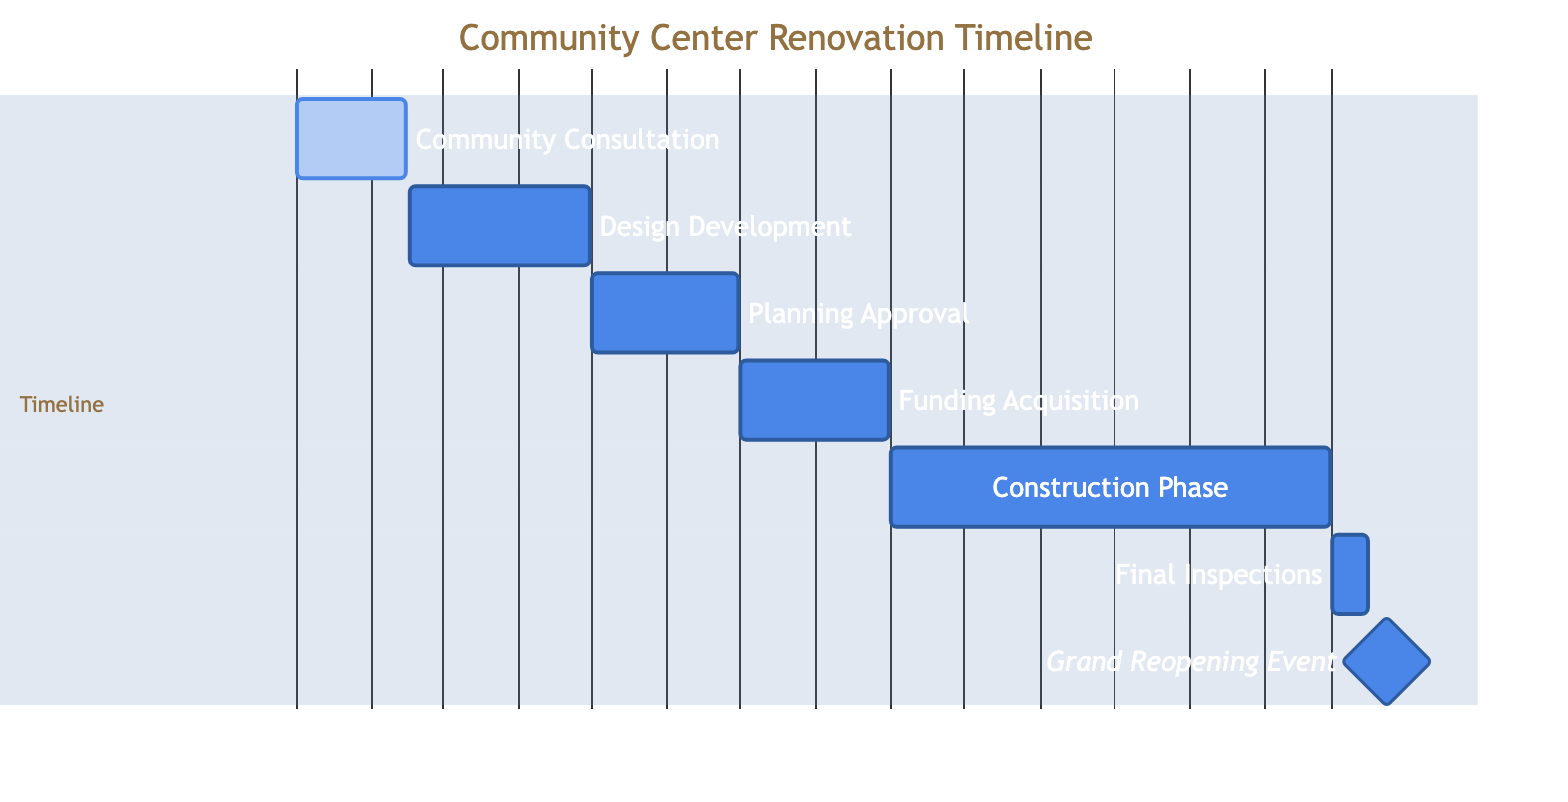What is the duration of the Construction Phase? The Construction Phase starts on September 1, 2024, and ends on February 28, 2025. To find the duration, you count from the start date to the end date, which gives you a total of 181 days.
Answer: 181 days What phase follows Planning Approval? After the Planning Approval phase, the next phase indicated on the diagram is Funding Acquisition. This can be concluded by observing the sequence of phases listed in the timeline.
Answer: Funding Acquisition How many phases are in the timeline? The timeline contains seven listed phases, which can be counted directly from the Gantt chart's sections. Each entry in the timeline represents a distinct phase of the project.
Answer: Seven phases What is the end date of the Grand Reopening Event? The Grand Reopening Event phase is scheduled to conclude on March 30, 2025. This can be ascertained by looking at the end date specified for this phase in the diagram.
Answer: March 30, 2025 During which month does the Design Development phase start? The Design Development phase begins on February 16, 2024. To identify the month, you can look at the start date provided for this particular phase in the Gantt chart.
Answer: February Which phase has the longest duration? The Construction Phase has the longest duration, running from September 1, 2024, to February 28, 2025, totaling 181 days. By comparing the lengths of all the phases, it is clear that this phase spans the most extended time period.
Answer: Construction Phase What is the immediate task after obtaining Planning Approval? Following Planning Approval, the immediate task is Funding Acquisition. This can be seen by examining the order of phases in the Gantt chart, where Funding Acquisition directly follows Planning Approval.
Answer: Funding Acquisition What is the purpose of the Community Consultation phase? The purpose of the Community Consultation phase, as stated in the description, is to gather input and ideas from local residents and stakeholders. This description is explicitly shown in conjunction with this phase.
Answer: Gather input and ideas 